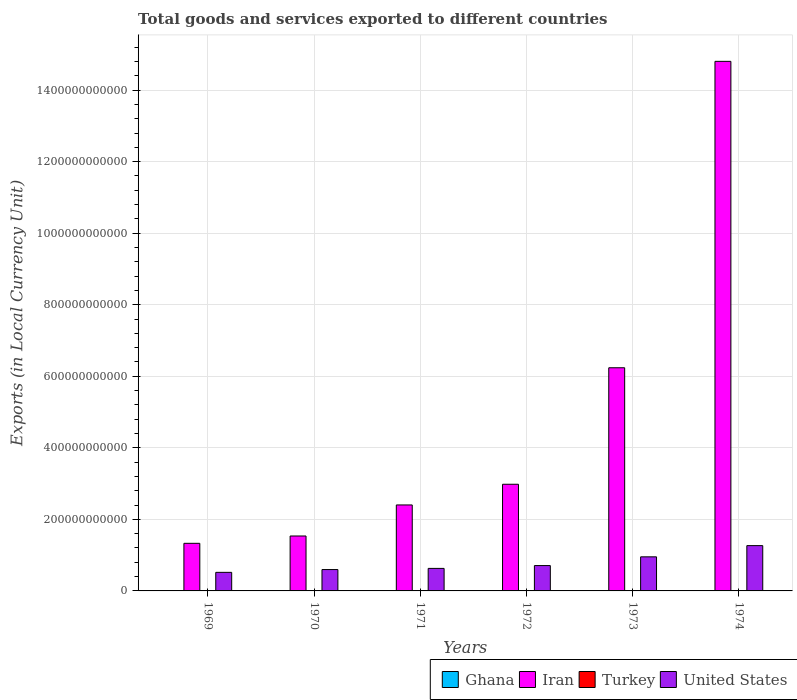How many bars are there on the 2nd tick from the left?
Make the answer very short. 4. What is the label of the 6th group of bars from the left?
Provide a succinct answer. 1974. What is the Amount of goods and services exports in Iran in 1973?
Give a very brief answer. 6.24e+11. Across all years, what is the maximum Amount of goods and services exports in Turkey?
Provide a short and direct response. 2.84e+04. Across all years, what is the minimum Amount of goods and services exports in Ghana?
Keep it short and to the point. 3.94e+04. In which year was the Amount of goods and services exports in Turkey maximum?
Make the answer very short. 1974. In which year was the Amount of goods and services exports in Turkey minimum?
Provide a short and direct response. 1969. What is the total Amount of goods and services exports in Ghana in the graph?
Provide a short and direct response. 3.46e+05. What is the difference between the Amount of goods and services exports in Iran in 1969 and that in 1972?
Make the answer very short. -1.65e+11. What is the difference between the Amount of goods and services exports in Ghana in 1969 and the Amount of goods and services exports in United States in 1972?
Your response must be concise. -7.08e+1. What is the average Amount of goods and services exports in Iran per year?
Make the answer very short. 4.88e+11. In the year 1973, what is the difference between the Amount of goods and services exports in Ghana and Amount of goods and services exports in Iran?
Provide a succinct answer. -6.24e+11. What is the ratio of the Amount of goods and services exports in Turkey in 1969 to that in 1971?
Your answer should be compact. 0.49. Is the difference between the Amount of goods and services exports in Ghana in 1970 and 1973 greater than the difference between the Amount of goods and services exports in Iran in 1970 and 1973?
Keep it short and to the point. Yes. What is the difference between the highest and the second highest Amount of goods and services exports in Turkey?
Your answer should be very brief. 2800. What is the difference between the highest and the lowest Amount of goods and services exports in Turkey?
Give a very brief answer. 2.21e+04. In how many years, is the Amount of goods and services exports in Turkey greater than the average Amount of goods and services exports in Turkey taken over all years?
Make the answer very short. 3. Is the sum of the Amount of goods and services exports in Turkey in 1971 and 1972 greater than the maximum Amount of goods and services exports in United States across all years?
Ensure brevity in your answer.  No. What does the 2nd bar from the left in 1970 represents?
Your answer should be compact. Iran. Is it the case that in every year, the sum of the Amount of goods and services exports in United States and Amount of goods and services exports in Iran is greater than the Amount of goods and services exports in Turkey?
Keep it short and to the point. Yes. Are all the bars in the graph horizontal?
Ensure brevity in your answer.  No. How many years are there in the graph?
Your answer should be very brief. 6. What is the difference between two consecutive major ticks on the Y-axis?
Ensure brevity in your answer.  2.00e+11. Are the values on the major ticks of Y-axis written in scientific E-notation?
Provide a succinct answer. No. How are the legend labels stacked?
Make the answer very short. Horizontal. What is the title of the graph?
Your answer should be very brief. Total goods and services exported to different countries. What is the label or title of the X-axis?
Provide a succinct answer. Years. What is the label or title of the Y-axis?
Your answer should be compact. Exports (in Local Currency Unit). What is the Exports (in Local Currency Unit) of Ghana in 1969?
Your response must be concise. 3.95e+04. What is the Exports (in Local Currency Unit) in Iran in 1969?
Keep it short and to the point. 1.33e+11. What is the Exports (in Local Currency Unit) of Turkey in 1969?
Make the answer very short. 6300. What is the Exports (in Local Currency Unit) in United States in 1969?
Your answer should be compact. 5.19e+1. What is the Exports (in Local Currency Unit) of Ghana in 1970?
Make the answer very short. 4.82e+04. What is the Exports (in Local Currency Unit) in Iran in 1970?
Your response must be concise. 1.54e+11. What is the Exports (in Local Currency Unit) in Turkey in 1970?
Ensure brevity in your answer.  8700. What is the Exports (in Local Currency Unit) of United States in 1970?
Provide a succinct answer. 5.97e+1. What is the Exports (in Local Currency Unit) of Ghana in 1971?
Your answer should be very brief. 3.94e+04. What is the Exports (in Local Currency Unit) of Iran in 1971?
Offer a terse response. 2.40e+11. What is the Exports (in Local Currency Unit) in Turkey in 1971?
Offer a terse response. 1.29e+04. What is the Exports (in Local Currency Unit) in United States in 1971?
Provide a succinct answer. 6.30e+1. What is the Exports (in Local Currency Unit) of Ghana in 1972?
Offer a terse response. 5.83e+04. What is the Exports (in Local Currency Unit) of Iran in 1972?
Your answer should be very brief. 2.98e+11. What is the Exports (in Local Currency Unit) of Turkey in 1972?
Offer a very short reply. 1.74e+04. What is the Exports (in Local Currency Unit) of United States in 1972?
Offer a very short reply. 7.08e+1. What is the Exports (in Local Currency Unit) in Ghana in 1973?
Provide a succinct answer. 7.51e+04. What is the Exports (in Local Currency Unit) in Iran in 1973?
Provide a short and direct response. 6.24e+11. What is the Exports (in Local Currency Unit) in Turkey in 1973?
Your answer should be compact. 2.56e+04. What is the Exports (in Local Currency Unit) in United States in 1973?
Ensure brevity in your answer.  9.53e+1. What is the Exports (in Local Currency Unit) of Ghana in 1974?
Make the answer very short. 8.54e+04. What is the Exports (in Local Currency Unit) of Iran in 1974?
Offer a terse response. 1.48e+12. What is the Exports (in Local Currency Unit) in Turkey in 1974?
Provide a succinct answer. 2.84e+04. What is the Exports (in Local Currency Unit) of United States in 1974?
Your answer should be compact. 1.27e+11. Across all years, what is the maximum Exports (in Local Currency Unit) of Ghana?
Your answer should be very brief. 8.54e+04. Across all years, what is the maximum Exports (in Local Currency Unit) in Iran?
Provide a short and direct response. 1.48e+12. Across all years, what is the maximum Exports (in Local Currency Unit) in Turkey?
Make the answer very short. 2.84e+04. Across all years, what is the maximum Exports (in Local Currency Unit) in United States?
Your answer should be very brief. 1.27e+11. Across all years, what is the minimum Exports (in Local Currency Unit) in Ghana?
Offer a terse response. 3.94e+04. Across all years, what is the minimum Exports (in Local Currency Unit) of Iran?
Your answer should be compact. 1.33e+11. Across all years, what is the minimum Exports (in Local Currency Unit) of Turkey?
Give a very brief answer. 6300. Across all years, what is the minimum Exports (in Local Currency Unit) in United States?
Give a very brief answer. 5.19e+1. What is the total Exports (in Local Currency Unit) in Ghana in the graph?
Provide a succinct answer. 3.46e+05. What is the total Exports (in Local Currency Unit) in Iran in the graph?
Make the answer very short. 2.93e+12. What is the total Exports (in Local Currency Unit) of Turkey in the graph?
Your answer should be very brief. 9.93e+04. What is the total Exports (in Local Currency Unit) in United States in the graph?
Ensure brevity in your answer.  4.67e+11. What is the difference between the Exports (in Local Currency Unit) of Ghana in 1969 and that in 1970?
Ensure brevity in your answer.  -8700. What is the difference between the Exports (in Local Currency Unit) in Iran in 1969 and that in 1970?
Your answer should be compact. -2.05e+1. What is the difference between the Exports (in Local Currency Unit) of Turkey in 1969 and that in 1970?
Provide a short and direct response. -2400. What is the difference between the Exports (in Local Currency Unit) in United States in 1969 and that in 1970?
Provide a succinct answer. -7.81e+09. What is the difference between the Exports (in Local Currency Unit) of Iran in 1969 and that in 1971?
Your response must be concise. -1.07e+11. What is the difference between the Exports (in Local Currency Unit) in Turkey in 1969 and that in 1971?
Give a very brief answer. -6600. What is the difference between the Exports (in Local Currency Unit) of United States in 1969 and that in 1971?
Provide a short and direct response. -1.11e+1. What is the difference between the Exports (in Local Currency Unit) in Ghana in 1969 and that in 1972?
Make the answer very short. -1.88e+04. What is the difference between the Exports (in Local Currency Unit) of Iran in 1969 and that in 1972?
Your answer should be compact. -1.65e+11. What is the difference between the Exports (in Local Currency Unit) in Turkey in 1969 and that in 1972?
Make the answer very short. -1.11e+04. What is the difference between the Exports (in Local Currency Unit) in United States in 1969 and that in 1972?
Make the answer very short. -1.89e+1. What is the difference between the Exports (in Local Currency Unit) in Ghana in 1969 and that in 1973?
Ensure brevity in your answer.  -3.56e+04. What is the difference between the Exports (in Local Currency Unit) of Iran in 1969 and that in 1973?
Make the answer very short. -4.91e+11. What is the difference between the Exports (in Local Currency Unit) in Turkey in 1969 and that in 1973?
Offer a terse response. -1.93e+04. What is the difference between the Exports (in Local Currency Unit) in United States in 1969 and that in 1973?
Provide a succinct answer. -4.34e+1. What is the difference between the Exports (in Local Currency Unit) of Ghana in 1969 and that in 1974?
Ensure brevity in your answer.  -4.59e+04. What is the difference between the Exports (in Local Currency Unit) in Iran in 1969 and that in 1974?
Give a very brief answer. -1.35e+12. What is the difference between the Exports (in Local Currency Unit) of Turkey in 1969 and that in 1974?
Offer a very short reply. -2.21e+04. What is the difference between the Exports (in Local Currency Unit) of United States in 1969 and that in 1974?
Provide a succinct answer. -7.48e+1. What is the difference between the Exports (in Local Currency Unit) in Ghana in 1970 and that in 1971?
Your answer should be compact. 8800. What is the difference between the Exports (in Local Currency Unit) of Iran in 1970 and that in 1971?
Keep it short and to the point. -8.68e+1. What is the difference between the Exports (in Local Currency Unit) of Turkey in 1970 and that in 1971?
Make the answer very short. -4200. What is the difference between the Exports (in Local Currency Unit) of United States in 1970 and that in 1971?
Offer a very short reply. -3.25e+09. What is the difference between the Exports (in Local Currency Unit) in Ghana in 1970 and that in 1972?
Your answer should be very brief. -1.01e+04. What is the difference between the Exports (in Local Currency Unit) of Iran in 1970 and that in 1972?
Give a very brief answer. -1.45e+11. What is the difference between the Exports (in Local Currency Unit) of Turkey in 1970 and that in 1972?
Offer a terse response. -8700. What is the difference between the Exports (in Local Currency Unit) of United States in 1970 and that in 1972?
Provide a succinct answer. -1.11e+1. What is the difference between the Exports (in Local Currency Unit) in Ghana in 1970 and that in 1973?
Provide a succinct answer. -2.69e+04. What is the difference between the Exports (in Local Currency Unit) of Iran in 1970 and that in 1973?
Provide a succinct answer. -4.70e+11. What is the difference between the Exports (in Local Currency Unit) in Turkey in 1970 and that in 1973?
Ensure brevity in your answer.  -1.69e+04. What is the difference between the Exports (in Local Currency Unit) in United States in 1970 and that in 1973?
Keep it short and to the point. -3.56e+1. What is the difference between the Exports (in Local Currency Unit) in Ghana in 1970 and that in 1974?
Give a very brief answer. -3.72e+04. What is the difference between the Exports (in Local Currency Unit) in Iran in 1970 and that in 1974?
Your answer should be compact. -1.33e+12. What is the difference between the Exports (in Local Currency Unit) in Turkey in 1970 and that in 1974?
Provide a succinct answer. -1.97e+04. What is the difference between the Exports (in Local Currency Unit) of United States in 1970 and that in 1974?
Your answer should be compact. -6.69e+1. What is the difference between the Exports (in Local Currency Unit) of Ghana in 1971 and that in 1972?
Make the answer very short. -1.89e+04. What is the difference between the Exports (in Local Currency Unit) in Iran in 1971 and that in 1972?
Give a very brief answer. -5.78e+1. What is the difference between the Exports (in Local Currency Unit) in Turkey in 1971 and that in 1972?
Your answer should be compact. -4500. What is the difference between the Exports (in Local Currency Unit) in United States in 1971 and that in 1972?
Give a very brief answer. -7.88e+09. What is the difference between the Exports (in Local Currency Unit) in Ghana in 1971 and that in 1973?
Your response must be concise. -3.57e+04. What is the difference between the Exports (in Local Currency Unit) of Iran in 1971 and that in 1973?
Your answer should be very brief. -3.83e+11. What is the difference between the Exports (in Local Currency Unit) of Turkey in 1971 and that in 1973?
Your response must be concise. -1.27e+04. What is the difference between the Exports (in Local Currency Unit) in United States in 1971 and that in 1973?
Your answer should be very brief. -3.23e+1. What is the difference between the Exports (in Local Currency Unit) of Ghana in 1971 and that in 1974?
Make the answer very short. -4.60e+04. What is the difference between the Exports (in Local Currency Unit) in Iran in 1971 and that in 1974?
Provide a succinct answer. -1.24e+12. What is the difference between the Exports (in Local Currency Unit) in Turkey in 1971 and that in 1974?
Provide a short and direct response. -1.55e+04. What is the difference between the Exports (in Local Currency Unit) in United States in 1971 and that in 1974?
Your answer should be compact. -6.37e+1. What is the difference between the Exports (in Local Currency Unit) in Ghana in 1972 and that in 1973?
Your response must be concise. -1.68e+04. What is the difference between the Exports (in Local Currency Unit) in Iran in 1972 and that in 1973?
Give a very brief answer. -3.26e+11. What is the difference between the Exports (in Local Currency Unit) in Turkey in 1972 and that in 1973?
Provide a short and direct response. -8200. What is the difference between the Exports (in Local Currency Unit) of United States in 1972 and that in 1973?
Your response must be concise. -2.44e+1. What is the difference between the Exports (in Local Currency Unit) in Ghana in 1972 and that in 1974?
Make the answer very short. -2.71e+04. What is the difference between the Exports (in Local Currency Unit) of Iran in 1972 and that in 1974?
Your answer should be compact. -1.18e+12. What is the difference between the Exports (in Local Currency Unit) of Turkey in 1972 and that in 1974?
Provide a short and direct response. -1.10e+04. What is the difference between the Exports (in Local Currency Unit) of United States in 1972 and that in 1974?
Your answer should be very brief. -5.58e+1. What is the difference between the Exports (in Local Currency Unit) in Ghana in 1973 and that in 1974?
Your answer should be compact. -1.03e+04. What is the difference between the Exports (in Local Currency Unit) in Iran in 1973 and that in 1974?
Offer a very short reply. -8.56e+11. What is the difference between the Exports (in Local Currency Unit) in Turkey in 1973 and that in 1974?
Make the answer very short. -2800. What is the difference between the Exports (in Local Currency Unit) in United States in 1973 and that in 1974?
Provide a short and direct response. -3.14e+1. What is the difference between the Exports (in Local Currency Unit) of Ghana in 1969 and the Exports (in Local Currency Unit) of Iran in 1970?
Give a very brief answer. -1.54e+11. What is the difference between the Exports (in Local Currency Unit) of Ghana in 1969 and the Exports (in Local Currency Unit) of Turkey in 1970?
Provide a short and direct response. 3.08e+04. What is the difference between the Exports (in Local Currency Unit) of Ghana in 1969 and the Exports (in Local Currency Unit) of United States in 1970?
Your answer should be compact. -5.97e+1. What is the difference between the Exports (in Local Currency Unit) in Iran in 1969 and the Exports (in Local Currency Unit) in Turkey in 1970?
Offer a very short reply. 1.33e+11. What is the difference between the Exports (in Local Currency Unit) of Iran in 1969 and the Exports (in Local Currency Unit) of United States in 1970?
Give a very brief answer. 7.33e+1. What is the difference between the Exports (in Local Currency Unit) in Turkey in 1969 and the Exports (in Local Currency Unit) in United States in 1970?
Provide a short and direct response. -5.97e+1. What is the difference between the Exports (in Local Currency Unit) of Ghana in 1969 and the Exports (in Local Currency Unit) of Iran in 1971?
Make the answer very short. -2.40e+11. What is the difference between the Exports (in Local Currency Unit) in Ghana in 1969 and the Exports (in Local Currency Unit) in Turkey in 1971?
Your answer should be very brief. 2.66e+04. What is the difference between the Exports (in Local Currency Unit) of Ghana in 1969 and the Exports (in Local Currency Unit) of United States in 1971?
Your answer should be very brief. -6.30e+1. What is the difference between the Exports (in Local Currency Unit) of Iran in 1969 and the Exports (in Local Currency Unit) of Turkey in 1971?
Give a very brief answer. 1.33e+11. What is the difference between the Exports (in Local Currency Unit) in Iran in 1969 and the Exports (in Local Currency Unit) in United States in 1971?
Make the answer very short. 7.01e+1. What is the difference between the Exports (in Local Currency Unit) in Turkey in 1969 and the Exports (in Local Currency Unit) in United States in 1971?
Keep it short and to the point. -6.30e+1. What is the difference between the Exports (in Local Currency Unit) in Ghana in 1969 and the Exports (in Local Currency Unit) in Iran in 1972?
Offer a terse response. -2.98e+11. What is the difference between the Exports (in Local Currency Unit) of Ghana in 1969 and the Exports (in Local Currency Unit) of Turkey in 1972?
Offer a very short reply. 2.21e+04. What is the difference between the Exports (in Local Currency Unit) in Ghana in 1969 and the Exports (in Local Currency Unit) in United States in 1972?
Give a very brief answer. -7.08e+1. What is the difference between the Exports (in Local Currency Unit) of Iran in 1969 and the Exports (in Local Currency Unit) of Turkey in 1972?
Keep it short and to the point. 1.33e+11. What is the difference between the Exports (in Local Currency Unit) of Iran in 1969 and the Exports (in Local Currency Unit) of United States in 1972?
Ensure brevity in your answer.  6.22e+1. What is the difference between the Exports (in Local Currency Unit) in Turkey in 1969 and the Exports (in Local Currency Unit) in United States in 1972?
Provide a succinct answer. -7.08e+1. What is the difference between the Exports (in Local Currency Unit) of Ghana in 1969 and the Exports (in Local Currency Unit) of Iran in 1973?
Provide a succinct answer. -6.24e+11. What is the difference between the Exports (in Local Currency Unit) in Ghana in 1969 and the Exports (in Local Currency Unit) in Turkey in 1973?
Your answer should be compact. 1.39e+04. What is the difference between the Exports (in Local Currency Unit) of Ghana in 1969 and the Exports (in Local Currency Unit) of United States in 1973?
Provide a succinct answer. -9.53e+1. What is the difference between the Exports (in Local Currency Unit) in Iran in 1969 and the Exports (in Local Currency Unit) in Turkey in 1973?
Provide a succinct answer. 1.33e+11. What is the difference between the Exports (in Local Currency Unit) of Iran in 1969 and the Exports (in Local Currency Unit) of United States in 1973?
Offer a terse response. 3.78e+1. What is the difference between the Exports (in Local Currency Unit) in Turkey in 1969 and the Exports (in Local Currency Unit) in United States in 1973?
Make the answer very short. -9.53e+1. What is the difference between the Exports (in Local Currency Unit) in Ghana in 1969 and the Exports (in Local Currency Unit) in Iran in 1974?
Your answer should be very brief. -1.48e+12. What is the difference between the Exports (in Local Currency Unit) of Ghana in 1969 and the Exports (in Local Currency Unit) of Turkey in 1974?
Keep it short and to the point. 1.11e+04. What is the difference between the Exports (in Local Currency Unit) in Ghana in 1969 and the Exports (in Local Currency Unit) in United States in 1974?
Provide a short and direct response. -1.27e+11. What is the difference between the Exports (in Local Currency Unit) in Iran in 1969 and the Exports (in Local Currency Unit) in Turkey in 1974?
Make the answer very short. 1.33e+11. What is the difference between the Exports (in Local Currency Unit) of Iran in 1969 and the Exports (in Local Currency Unit) of United States in 1974?
Your answer should be very brief. 6.40e+09. What is the difference between the Exports (in Local Currency Unit) of Turkey in 1969 and the Exports (in Local Currency Unit) of United States in 1974?
Offer a terse response. -1.27e+11. What is the difference between the Exports (in Local Currency Unit) in Ghana in 1970 and the Exports (in Local Currency Unit) in Iran in 1971?
Provide a short and direct response. -2.40e+11. What is the difference between the Exports (in Local Currency Unit) of Ghana in 1970 and the Exports (in Local Currency Unit) of Turkey in 1971?
Give a very brief answer. 3.53e+04. What is the difference between the Exports (in Local Currency Unit) in Ghana in 1970 and the Exports (in Local Currency Unit) in United States in 1971?
Make the answer very short. -6.30e+1. What is the difference between the Exports (in Local Currency Unit) in Iran in 1970 and the Exports (in Local Currency Unit) in Turkey in 1971?
Your response must be concise. 1.54e+11. What is the difference between the Exports (in Local Currency Unit) in Iran in 1970 and the Exports (in Local Currency Unit) in United States in 1971?
Make the answer very short. 9.06e+1. What is the difference between the Exports (in Local Currency Unit) in Turkey in 1970 and the Exports (in Local Currency Unit) in United States in 1971?
Offer a terse response. -6.30e+1. What is the difference between the Exports (in Local Currency Unit) in Ghana in 1970 and the Exports (in Local Currency Unit) in Iran in 1972?
Provide a short and direct response. -2.98e+11. What is the difference between the Exports (in Local Currency Unit) of Ghana in 1970 and the Exports (in Local Currency Unit) of Turkey in 1972?
Provide a short and direct response. 3.08e+04. What is the difference between the Exports (in Local Currency Unit) in Ghana in 1970 and the Exports (in Local Currency Unit) in United States in 1972?
Make the answer very short. -7.08e+1. What is the difference between the Exports (in Local Currency Unit) of Iran in 1970 and the Exports (in Local Currency Unit) of Turkey in 1972?
Ensure brevity in your answer.  1.54e+11. What is the difference between the Exports (in Local Currency Unit) in Iran in 1970 and the Exports (in Local Currency Unit) in United States in 1972?
Your answer should be compact. 8.27e+1. What is the difference between the Exports (in Local Currency Unit) of Turkey in 1970 and the Exports (in Local Currency Unit) of United States in 1972?
Provide a succinct answer. -7.08e+1. What is the difference between the Exports (in Local Currency Unit) of Ghana in 1970 and the Exports (in Local Currency Unit) of Iran in 1973?
Provide a succinct answer. -6.24e+11. What is the difference between the Exports (in Local Currency Unit) of Ghana in 1970 and the Exports (in Local Currency Unit) of Turkey in 1973?
Your answer should be very brief. 2.26e+04. What is the difference between the Exports (in Local Currency Unit) in Ghana in 1970 and the Exports (in Local Currency Unit) in United States in 1973?
Provide a succinct answer. -9.53e+1. What is the difference between the Exports (in Local Currency Unit) of Iran in 1970 and the Exports (in Local Currency Unit) of Turkey in 1973?
Your response must be concise. 1.54e+11. What is the difference between the Exports (in Local Currency Unit) of Iran in 1970 and the Exports (in Local Currency Unit) of United States in 1973?
Your answer should be compact. 5.83e+1. What is the difference between the Exports (in Local Currency Unit) in Turkey in 1970 and the Exports (in Local Currency Unit) in United States in 1973?
Give a very brief answer. -9.53e+1. What is the difference between the Exports (in Local Currency Unit) in Ghana in 1970 and the Exports (in Local Currency Unit) in Iran in 1974?
Offer a terse response. -1.48e+12. What is the difference between the Exports (in Local Currency Unit) in Ghana in 1970 and the Exports (in Local Currency Unit) in Turkey in 1974?
Offer a very short reply. 1.98e+04. What is the difference between the Exports (in Local Currency Unit) of Ghana in 1970 and the Exports (in Local Currency Unit) of United States in 1974?
Offer a terse response. -1.27e+11. What is the difference between the Exports (in Local Currency Unit) in Iran in 1970 and the Exports (in Local Currency Unit) in Turkey in 1974?
Provide a short and direct response. 1.54e+11. What is the difference between the Exports (in Local Currency Unit) in Iran in 1970 and the Exports (in Local Currency Unit) in United States in 1974?
Your response must be concise. 2.69e+1. What is the difference between the Exports (in Local Currency Unit) of Turkey in 1970 and the Exports (in Local Currency Unit) of United States in 1974?
Give a very brief answer. -1.27e+11. What is the difference between the Exports (in Local Currency Unit) in Ghana in 1971 and the Exports (in Local Currency Unit) in Iran in 1972?
Your response must be concise. -2.98e+11. What is the difference between the Exports (in Local Currency Unit) in Ghana in 1971 and the Exports (in Local Currency Unit) in Turkey in 1972?
Give a very brief answer. 2.20e+04. What is the difference between the Exports (in Local Currency Unit) of Ghana in 1971 and the Exports (in Local Currency Unit) of United States in 1972?
Offer a terse response. -7.08e+1. What is the difference between the Exports (in Local Currency Unit) of Iran in 1971 and the Exports (in Local Currency Unit) of Turkey in 1972?
Give a very brief answer. 2.40e+11. What is the difference between the Exports (in Local Currency Unit) in Iran in 1971 and the Exports (in Local Currency Unit) in United States in 1972?
Keep it short and to the point. 1.69e+11. What is the difference between the Exports (in Local Currency Unit) of Turkey in 1971 and the Exports (in Local Currency Unit) of United States in 1972?
Make the answer very short. -7.08e+1. What is the difference between the Exports (in Local Currency Unit) of Ghana in 1971 and the Exports (in Local Currency Unit) of Iran in 1973?
Offer a terse response. -6.24e+11. What is the difference between the Exports (in Local Currency Unit) of Ghana in 1971 and the Exports (in Local Currency Unit) of Turkey in 1973?
Your answer should be compact. 1.38e+04. What is the difference between the Exports (in Local Currency Unit) of Ghana in 1971 and the Exports (in Local Currency Unit) of United States in 1973?
Provide a succinct answer. -9.53e+1. What is the difference between the Exports (in Local Currency Unit) of Iran in 1971 and the Exports (in Local Currency Unit) of Turkey in 1973?
Your response must be concise. 2.40e+11. What is the difference between the Exports (in Local Currency Unit) of Iran in 1971 and the Exports (in Local Currency Unit) of United States in 1973?
Ensure brevity in your answer.  1.45e+11. What is the difference between the Exports (in Local Currency Unit) of Turkey in 1971 and the Exports (in Local Currency Unit) of United States in 1973?
Your response must be concise. -9.53e+1. What is the difference between the Exports (in Local Currency Unit) in Ghana in 1971 and the Exports (in Local Currency Unit) in Iran in 1974?
Ensure brevity in your answer.  -1.48e+12. What is the difference between the Exports (in Local Currency Unit) in Ghana in 1971 and the Exports (in Local Currency Unit) in Turkey in 1974?
Offer a terse response. 1.10e+04. What is the difference between the Exports (in Local Currency Unit) of Ghana in 1971 and the Exports (in Local Currency Unit) of United States in 1974?
Offer a very short reply. -1.27e+11. What is the difference between the Exports (in Local Currency Unit) of Iran in 1971 and the Exports (in Local Currency Unit) of Turkey in 1974?
Provide a short and direct response. 2.40e+11. What is the difference between the Exports (in Local Currency Unit) of Iran in 1971 and the Exports (in Local Currency Unit) of United States in 1974?
Provide a short and direct response. 1.14e+11. What is the difference between the Exports (in Local Currency Unit) of Turkey in 1971 and the Exports (in Local Currency Unit) of United States in 1974?
Keep it short and to the point. -1.27e+11. What is the difference between the Exports (in Local Currency Unit) of Ghana in 1972 and the Exports (in Local Currency Unit) of Iran in 1973?
Your answer should be compact. -6.24e+11. What is the difference between the Exports (in Local Currency Unit) in Ghana in 1972 and the Exports (in Local Currency Unit) in Turkey in 1973?
Provide a short and direct response. 3.27e+04. What is the difference between the Exports (in Local Currency Unit) in Ghana in 1972 and the Exports (in Local Currency Unit) in United States in 1973?
Your response must be concise. -9.53e+1. What is the difference between the Exports (in Local Currency Unit) of Iran in 1972 and the Exports (in Local Currency Unit) of Turkey in 1973?
Give a very brief answer. 2.98e+11. What is the difference between the Exports (in Local Currency Unit) in Iran in 1972 and the Exports (in Local Currency Unit) in United States in 1973?
Keep it short and to the point. 2.03e+11. What is the difference between the Exports (in Local Currency Unit) in Turkey in 1972 and the Exports (in Local Currency Unit) in United States in 1973?
Keep it short and to the point. -9.53e+1. What is the difference between the Exports (in Local Currency Unit) in Ghana in 1972 and the Exports (in Local Currency Unit) in Iran in 1974?
Provide a short and direct response. -1.48e+12. What is the difference between the Exports (in Local Currency Unit) of Ghana in 1972 and the Exports (in Local Currency Unit) of Turkey in 1974?
Offer a terse response. 2.99e+04. What is the difference between the Exports (in Local Currency Unit) in Ghana in 1972 and the Exports (in Local Currency Unit) in United States in 1974?
Provide a short and direct response. -1.27e+11. What is the difference between the Exports (in Local Currency Unit) in Iran in 1972 and the Exports (in Local Currency Unit) in Turkey in 1974?
Ensure brevity in your answer.  2.98e+11. What is the difference between the Exports (in Local Currency Unit) in Iran in 1972 and the Exports (in Local Currency Unit) in United States in 1974?
Give a very brief answer. 1.72e+11. What is the difference between the Exports (in Local Currency Unit) of Turkey in 1972 and the Exports (in Local Currency Unit) of United States in 1974?
Offer a terse response. -1.27e+11. What is the difference between the Exports (in Local Currency Unit) in Ghana in 1973 and the Exports (in Local Currency Unit) in Iran in 1974?
Ensure brevity in your answer.  -1.48e+12. What is the difference between the Exports (in Local Currency Unit) in Ghana in 1973 and the Exports (in Local Currency Unit) in Turkey in 1974?
Your response must be concise. 4.67e+04. What is the difference between the Exports (in Local Currency Unit) in Ghana in 1973 and the Exports (in Local Currency Unit) in United States in 1974?
Your response must be concise. -1.27e+11. What is the difference between the Exports (in Local Currency Unit) of Iran in 1973 and the Exports (in Local Currency Unit) of Turkey in 1974?
Offer a terse response. 6.24e+11. What is the difference between the Exports (in Local Currency Unit) of Iran in 1973 and the Exports (in Local Currency Unit) of United States in 1974?
Offer a very short reply. 4.97e+11. What is the difference between the Exports (in Local Currency Unit) of Turkey in 1973 and the Exports (in Local Currency Unit) of United States in 1974?
Your answer should be very brief. -1.27e+11. What is the average Exports (in Local Currency Unit) in Ghana per year?
Offer a terse response. 5.76e+04. What is the average Exports (in Local Currency Unit) in Iran per year?
Provide a succinct answer. 4.88e+11. What is the average Exports (in Local Currency Unit) of Turkey per year?
Your response must be concise. 1.66e+04. What is the average Exports (in Local Currency Unit) of United States per year?
Offer a terse response. 7.79e+1. In the year 1969, what is the difference between the Exports (in Local Currency Unit) of Ghana and Exports (in Local Currency Unit) of Iran?
Keep it short and to the point. -1.33e+11. In the year 1969, what is the difference between the Exports (in Local Currency Unit) in Ghana and Exports (in Local Currency Unit) in Turkey?
Give a very brief answer. 3.32e+04. In the year 1969, what is the difference between the Exports (in Local Currency Unit) in Ghana and Exports (in Local Currency Unit) in United States?
Offer a very short reply. -5.19e+1. In the year 1969, what is the difference between the Exports (in Local Currency Unit) in Iran and Exports (in Local Currency Unit) in Turkey?
Offer a terse response. 1.33e+11. In the year 1969, what is the difference between the Exports (in Local Currency Unit) of Iran and Exports (in Local Currency Unit) of United States?
Offer a terse response. 8.12e+1. In the year 1969, what is the difference between the Exports (in Local Currency Unit) in Turkey and Exports (in Local Currency Unit) in United States?
Your answer should be very brief. -5.19e+1. In the year 1970, what is the difference between the Exports (in Local Currency Unit) of Ghana and Exports (in Local Currency Unit) of Iran?
Provide a succinct answer. -1.54e+11. In the year 1970, what is the difference between the Exports (in Local Currency Unit) of Ghana and Exports (in Local Currency Unit) of Turkey?
Your response must be concise. 3.95e+04. In the year 1970, what is the difference between the Exports (in Local Currency Unit) in Ghana and Exports (in Local Currency Unit) in United States?
Provide a succinct answer. -5.97e+1. In the year 1970, what is the difference between the Exports (in Local Currency Unit) in Iran and Exports (in Local Currency Unit) in Turkey?
Give a very brief answer. 1.54e+11. In the year 1970, what is the difference between the Exports (in Local Currency Unit) in Iran and Exports (in Local Currency Unit) in United States?
Make the answer very short. 9.38e+1. In the year 1970, what is the difference between the Exports (in Local Currency Unit) of Turkey and Exports (in Local Currency Unit) of United States?
Your answer should be very brief. -5.97e+1. In the year 1971, what is the difference between the Exports (in Local Currency Unit) of Ghana and Exports (in Local Currency Unit) of Iran?
Offer a terse response. -2.40e+11. In the year 1971, what is the difference between the Exports (in Local Currency Unit) of Ghana and Exports (in Local Currency Unit) of Turkey?
Ensure brevity in your answer.  2.65e+04. In the year 1971, what is the difference between the Exports (in Local Currency Unit) in Ghana and Exports (in Local Currency Unit) in United States?
Your answer should be compact. -6.30e+1. In the year 1971, what is the difference between the Exports (in Local Currency Unit) in Iran and Exports (in Local Currency Unit) in Turkey?
Provide a short and direct response. 2.40e+11. In the year 1971, what is the difference between the Exports (in Local Currency Unit) in Iran and Exports (in Local Currency Unit) in United States?
Keep it short and to the point. 1.77e+11. In the year 1971, what is the difference between the Exports (in Local Currency Unit) of Turkey and Exports (in Local Currency Unit) of United States?
Ensure brevity in your answer.  -6.30e+1. In the year 1972, what is the difference between the Exports (in Local Currency Unit) of Ghana and Exports (in Local Currency Unit) of Iran?
Your response must be concise. -2.98e+11. In the year 1972, what is the difference between the Exports (in Local Currency Unit) in Ghana and Exports (in Local Currency Unit) in Turkey?
Your answer should be very brief. 4.09e+04. In the year 1972, what is the difference between the Exports (in Local Currency Unit) of Ghana and Exports (in Local Currency Unit) of United States?
Keep it short and to the point. -7.08e+1. In the year 1972, what is the difference between the Exports (in Local Currency Unit) in Iran and Exports (in Local Currency Unit) in Turkey?
Offer a very short reply. 2.98e+11. In the year 1972, what is the difference between the Exports (in Local Currency Unit) in Iran and Exports (in Local Currency Unit) in United States?
Give a very brief answer. 2.27e+11. In the year 1972, what is the difference between the Exports (in Local Currency Unit) in Turkey and Exports (in Local Currency Unit) in United States?
Give a very brief answer. -7.08e+1. In the year 1973, what is the difference between the Exports (in Local Currency Unit) in Ghana and Exports (in Local Currency Unit) in Iran?
Offer a terse response. -6.24e+11. In the year 1973, what is the difference between the Exports (in Local Currency Unit) in Ghana and Exports (in Local Currency Unit) in Turkey?
Make the answer very short. 4.95e+04. In the year 1973, what is the difference between the Exports (in Local Currency Unit) in Ghana and Exports (in Local Currency Unit) in United States?
Provide a short and direct response. -9.53e+1. In the year 1973, what is the difference between the Exports (in Local Currency Unit) in Iran and Exports (in Local Currency Unit) in Turkey?
Offer a terse response. 6.24e+11. In the year 1973, what is the difference between the Exports (in Local Currency Unit) of Iran and Exports (in Local Currency Unit) of United States?
Ensure brevity in your answer.  5.29e+11. In the year 1973, what is the difference between the Exports (in Local Currency Unit) of Turkey and Exports (in Local Currency Unit) of United States?
Your answer should be very brief. -9.53e+1. In the year 1974, what is the difference between the Exports (in Local Currency Unit) of Ghana and Exports (in Local Currency Unit) of Iran?
Your response must be concise. -1.48e+12. In the year 1974, what is the difference between the Exports (in Local Currency Unit) of Ghana and Exports (in Local Currency Unit) of Turkey?
Make the answer very short. 5.70e+04. In the year 1974, what is the difference between the Exports (in Local Currency Unit) of Ghana and Exports (in Local Currency Unit) of United States?
Make the answer very short. -1.27e+11. In the year 1974, what is the difference between the Exports (in Local Currency Unit) in Iran and Exports (in Local Currency Unit) in Turkey?
Give a very brief answer. 1.48e+12. In the year 1974, what is the difference between the Exports (in Local Currency Unit) in Iran and Exports (in Local Currency Unit) in United States?
Your answer should be compact. 1.35e+12. In the year 1974, what is the difference between the Exports (in Local Currency Unit) of Turkey and Exports (in Local Currency Unit) of United States?
Your answer should be very brief. -1.27e+11. What is the ratio of the Exports (in Local Currency Unit) in Ghana in 1969 to that in 1970?
Make the answer very short. 0.82. What is the ratio of the Exports (in Local Currency Unit) in Iran in 1969 to that in 1970?
Provide a short and direct response. 0.87. What is the ratio of the Exports (in Local Currency Unit) in Turkey in 1969 to that in 1970?
Provide a succinct answer. 0.72. What is the ratio of the Exports (in Local Currency Unit) of United States in 1969 to that in 1970?
Provide a succinct answer. 0.87. What is the ratio of the Exports (in Local Currency Unit) of Iran in 1969 to that in 1971?
Ensure brevity in your answer.  0.55. What is the ratio of the Exports (in Local Currency Unit) of Turkey in 1969 to that in 1971?
Keep it short and to the point. 0.49. What is the ratio of the Exports (in Local Currency Unit) of United States in 1969 to that in 1971?
Ensure brevity in your answer.  0.82. What is the ratio of the Exports (in Local Currency Unit) in Ghana in 1969 to that in 1972?
Ensure brevity in your answer.  0.68. What is the ratio of the Exports (in Local Currency Unit) in Iran in 1969 to that in 1972?
Ensure brevity in your answer.  0.45. What is the ratio of the Exports (in Local Currency Unit) in Turkey in 1969 to that in 1972?
Make the answer very short. 0.36. What is the ratio of the Exports (in Local Currency Unit) of United States in 1969 to that in 1972?
Ensure brevity in your answer.  0.73. What is the ratio of the Exports (in Local Currency Unit) of Ghana in 1969 to that in 1973?
Make the answer very short. 0.53. What is the ratio of the Exports (in Local Currency Unit) of Iran in 1969 to that in 1973?
Your answer should be compact. 0.21. What is the ratio of the Exports (in Local Currency Unit) in Turkey in 1969 to that in 1973?
Make the answer very short. 0.25. What is the ratio of the Exports (in Local Currency Unit) in United States in 1969 to that in 1973?
Your answer should be very brief. 0.54. What is the ratio of the Exports (in Local Currency Unit) in Ghana in 1969 to that in 1974?
Your answer should be compact. 0.46. What is the ratio of the Exports (in Local Currency Unit) of Iran in 1969 to that in 1974?
Make the answer very short. 0.09. What is the ratio of the Exports (in Local Currency Unit) in Turkey in 1969 to that in 1974?
Your answer should be very brief. 0.22. What is the ratio of the Exports (in Local Currency Unit) of United States in 1969 to that in 1974?
Keep it short and to the point. 0.41. What is the ratio of the Exports (in Local Currency Unit) of Ghana in 1970 to that in 1971?
Provide a short and direct response. 1.22. What is the ratio of the Exports (in Local Currency Unit) in Iran in 1970 to that in 1971?
Your answer should be compact. 0.64. What is the ratio of the Exports (in Local Currency Unit) in Turkey in 1970 to that in 1971?
Keep it short and to the point. 0.67. What is the ratio of the Exports (in Local Currency Unit) of United States in 1970 to that in 1971?
Ensure brevity in your answer.  0.95. What is the ratio of the Exports (in Local Currency Unit) in Ghana in 1970 to that in 1972?
Give a very brief answer. 0.83. What is the ratio of the Exports (in Local Currency Unit) of Iran in 1970 to that in 1972?
Keep it short and to the point. 0.51. What is the ratio of the Exports (in Local Currency Unit) in United States in 1970 to that in 1972?
Make the answer very short. 0.84. What is the ratio of the Exports (in Local Currency Unit) of Ghana in 1970 to that in 1973?
Provide a succinct answer. 0.64. What is the ratio of the Exports (in Local Currency Unit) in Iran in 1970 to that in 1973?
Your answer should be very brief. 0.25. What is the ratio of the Exports (in Local Currency Unit) of Turkey in 1970 to that in 1973?
Your response must be concise. 0.34. What is the ratio of the Exports (in Local Currency Unit) in United States in 1970 to that in 1973?
Keep it short and to the point. 0.63. What is the ratio of the Exports (in Local Currency Unit) of Ghana in 1970 to that in 1974?
Keep it short and to the point. 0.56. What is the ratio of the Exports (in Local Currency Unit) in Iran in 1970 to that in 1974?
Make the answer very short. 0.1. What is the ratio of the Exports (in Local Currency Unit) of Turkey in 1970 to that in 1974?
Your answer should be compact. 0.31. What is the ratio of the Exports (in Local Currency Unit) in United States in 1970 to that in 1974?
Offer a terse response. 0.47. What is the ratio of the Exports (in Local Currency Unit) in Ghana in 1971 to that in 1972?
Your response must be concise. 0.68. What is the ratio of the Exports (in Local Currency Unit) in Iran in 1971 to that in 1972?
Provide a short and direct response. 0.81. What is the ratio of the Exports (in Local Currency Unit) in Turkey in 1971 to that in 1972?
Offer a terse response. 0.74. What is the ratio of the Exports (in Local Currency Unit) of United States in 1971 to that in 1972?
Your response must be concise. 0.89. What is the ratio of the Exports (in Local Currency Unit) in Ghana in 1971 to that in 1973?
Give a very brief answer. 0.52. What is the ratio of the Exports (in Local Currency Unit) in Iran in 1971 to that in 1973?
Your answer should be compact. 0.39. What is the ratio of the Exports (in Local Currency Unit) in Turkey in 1971 to that in 1973?
Make the answer very short. 0.5. What is the ratio of the Exports (in Local Currency Unit) of United States in 1971 to that in 1973?
Make the answer very short. 0.66. What is the ratio of the Exports (in Local Currency Unit) of Ghana in 1971 to that in 1974?
Your answer should be compact. 0.46. What is the ratio of the Exports (in Local Currency Unit) of Iran in 1971 to that in 1974?
Provide a succinct answer. 0.16. What is the ratio of the Exports (in Local Currency Unit) in Turkey in 1971 to that in 1974?
Give a very brief answer. 0.45. What is the ratio of the Exports (in Local Currency Unit) of United States in 1971 to that in 1974?
Keep it short and to the point. 0.5. What is the ratio of the Exports (in Local Currency Unit) in Ghana in 1972 to that in 1973?
Provide a succinct answer. 0.78. What is the ratio of the Exports (in Local Currency Unit) in Iran in 1972 to that in 1973?
Your answer should be compact. 0.48. What is the ratio of the Exports (in Local Currency Unit) of Turkey in 1972 to that in 1973?
Give a very brief answer. 0.68. What is the ratio of the Exports (in Local Currency Unit) in United States in 1972 to that in 1973?
Keep it short and to the point. 0.74. What is the ratio of the Exports (in Local Currency Unit) of Ghana in 1972 to that in 1974?
Make the answer very short. 0.68. What is the ratio of the Exports (in Local Currency Unit) of Iran in 1972 to that in 1974?
Your answer should be very brief. 0.2. What is the ratio of the Exports (in Local Currency Unit) of Turkey in 1972 to that in 1974?
Give a very brief answer. 0.61. What is the ratio of the Exports (in Local Currency Unit) in United States in 1972 to that in 1974?
Provide a succinct answer. 0.56. What is the ratio of the Exports (in Local Currency Unit) of Ghana in 1973 to that in 1974?
Your answer should be very brief. 0.88. What is the ratio of the Exports (in Local Currency Unit) in Iran in 1973 to that in 1974?
Your answer should be very brief. 0.42. What is the ratio of the Exports (in Local Currency Unit) of Turkey in 1973 to that in 1974?
Provide a succinct answer. 0.9. What is the ratio of the Exports (in Local Currency Unit) of United States in 1973 to that in 1974?
Provide a short and direct response. 0.75. What is the difference between the highest and the second highest Exports (in Local Currency Unit) in Ghana?
Offer a terse response. 1.03e+04. What is the difference between the highest and the second highest Exports (in Local Currency Unit) of Iran?
Keep it short and to the point. 8.56e+11. What is the difference between the highest and the second highest Exports (in Local Currency Unit) in Turkey?
Offer a very short reply. 2800. What is the difference between the highest and the second highest Exports (in Local Currency Unit) in United States?
Your answer should be compact. 3.14e+1. What is the difference between the highest and the lowest Exports (in Local Currency Unit) of Ghana?
Provide a succinct answer. 4.60e+04. What is the difference between the highest and the lowest Exports (in Local Currency Unit) in Iran?
Offer a very short reply. 1.35e+12. What is the difference between the highest and the lowest Exports (in Local Currency Unit) in Turkey?
Your answer should be compact. 2.21e+04. What is the difference between the highest and the lowest Exports (in Local Currency Unit) of United States?
Give a very brief answer. 7.48e+1. 